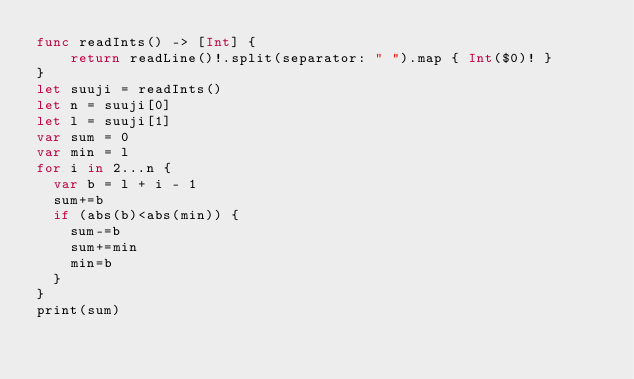Convert code to text. <code><loc_0><loc_0><loc_500><loc_500><_Swift_>func readInts() -> [Int] {
    return readLine()!.split(separator: " ").map { Int($0)! }
}
let suuji = readInts()
let n = suuji[0]
let l = suuji[1]
var sum = 0
var min = l
for i in 2...n {
  var b = l + i - 1
  sum+=b
  if (abs(b)<abs(min)) {
    sum-=b
    sum+=min
    min=b
  }
}
print(sum)</code> 